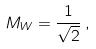Convert formula to latex. <formula><loc_0><loc_0><loc_500><loc_500>M _ { W } = \frac { 1 } { \sqrt { 2 } } \, ,</formula> 